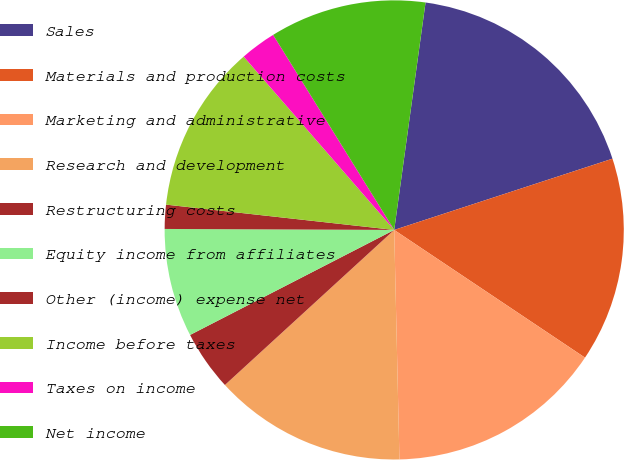Convert chart. <chart><loc_0><loc_0><loc_500><loc_500><pie_chart><fcel>Sales<fcel>Materials and production costs<fcel>Marketing and administrative<fcel>Research and development<fcel>Restructuring costs<fcel>Equity income from affiliates<fcel>Other (income) expense net<fcel>Income before taxes<fcel>Taxes on income<fcel>Net income<nl><fcel>17.8%<fcel>14.41%<fcel>15.25%<fcel>13.56%<fcel>4.24%<fcel>7.63%<fcel>1.69%<fcel>11.86%<fcel>2.54%<fcel>11.02%<nl></chart> 